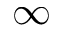Convert formula to latex. <formula><loc_0><loc_0><loc_500><loc_500>\infty</formula> 